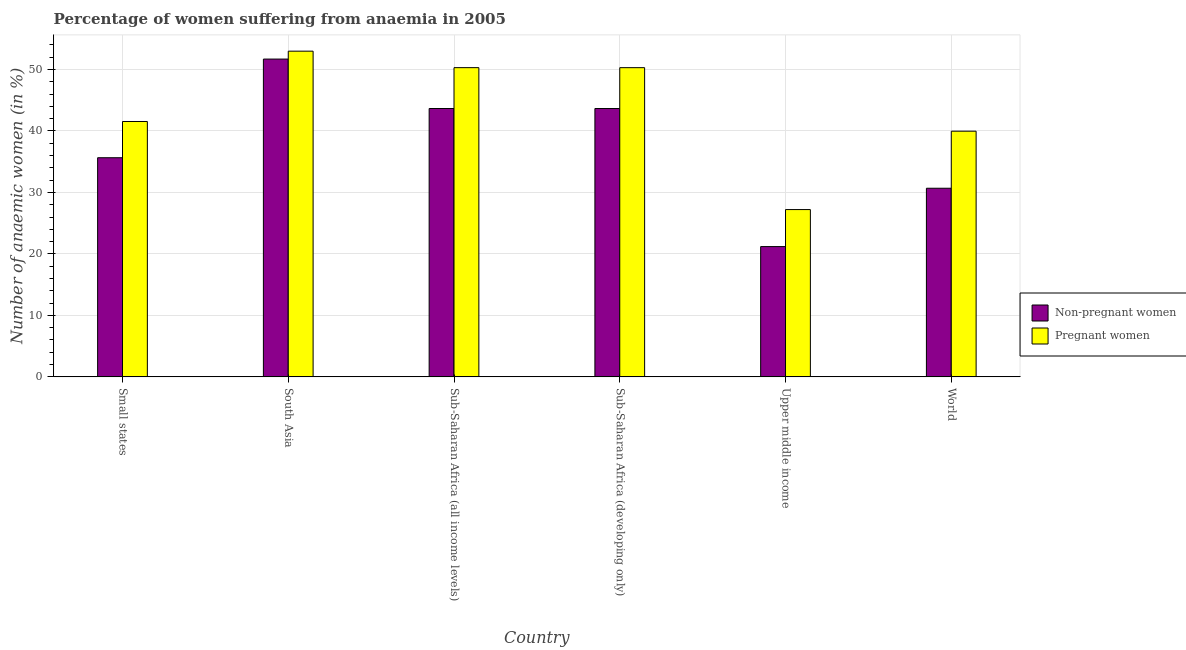How many different coloured bars are there?
Provide a succinct answer. 2. Are the number of bars per tick equal to the number of legend labels?
Make the answer very short. Yes. Are the number of bars on each tick of the X-axis equal?
Give a very brief answer. Yes. How many bars are there on the 4th tick from the left?
Ensure brevity in your answer.  2. What is the label of the 2nd group of bars from the left?
Your answer should be very brief. South Asia. What is the percentage of non-pregnant anaemic women in Sub-Saharan Africa (developing only)?
Offer a very short reply. 43.65. Across all countries, what is the maximum percentage of non-pregnant anaemic women?
Your answer should be very brief. 51.69. Across all countries, what is the minimum percentage of non-pregnant anaemic women?
Provide a succinct answer. 21.19. In which country was the percentage of pregnant anaemic women maximum?
Keep it short and to the point. South Asia. In which country was the percentage of non-pregnant anaemic women minimum?
Your answer should be compact. Upper middle income. What is the total percentage of pregnant anaemic women in the graph?
Your answer should be compact. 262.28. What is the difference between the percentage of non-pregnant anaemic women in South Asia and that in Upper middle income?
Ensure brevity in your answer.  30.5. What is the difference between the percentage of pregnant anaemic women in Small states and the percentage of non-pregnant anaemic women in Sub-Saharan Africa (developing only)?
Your response must be concise. -2.11. What is the average percentage of non-pregnant anaemic women per country?
Your answer should be very brief. 37.75. What is the difference between the percentage of non-pregnant anaemic women and percentage of pregnant anaemic women in Small states?
Provide a succinct answer. -5.89. What is the ratio of the percentage of non-pregnant anaemic women in South Asia to that in World?
Your answer should be compact. 1.68. Is the difference between the percentage of non-pregnant anaemic women in South Asia and Sub-Saharan Africa (all income levels) greater than the difference between the percentage of pregnant anaemic women in South Asia and Sub-Saharan Africa (all income levels)?
Keep it short and to the point. Yes. What is the difference between the highest and the second highest percentage of pregnant anaemic women?
Make the answer very short. 2.68. What is the difference between the highest and the lowest percentage of pregnant anaemic women?
Provide a succinct answer. 25.77. In how many countries, is the percentage of pregnant anaemic women greater than the average percentage of pregnant anaemic women taken over all countries?
Your answer should be very brief. 3. Is the sum of the percentage of non-pregnant anaemic women in Sub-Saharan Africa (developing only) and World greater than the maximum percentage of pregnant anaemic women across all countries?
Provide a succinct answer. Yes. What does the 1st bar from the left in Upper middle income represents?
Provide a short and direct response. Non-pregnant women. What does the 1st bar from the right in World represents?
Offer a terse response. Pregnant women. How many bars are there?
Provide a succinct answer. 12. How many countries are there in the graph?
Offer a very short reply. 6. What is the difference between two consecutive major ticks on the Y-axis?
Make the answer very short. 10. Are the values on the major ticks of Y-axis written in scientific E-notation?
Provide a succinct answer. No. Does the graph contain any zero values?
Keep it short and to the point. No. How many legend labels are there?
Keep it short and to the point. 2. How are the legend labels stacked?
Your answer should be very brief. Vertical. What is the title of the graph?
Ensure brevity in your answer.  Percentage of women suffering from anaemia in 2005. What is the label or title of the Y-axis?
Offer a very short reply. Number of anaemic women (in %). What is the Number of anaemic women (in %) of Non-pregnant women in Small states?
Keep it short and to the point. 35.65. What is the Number of anaemic women (in %) in Pregnant women in Small states?
Your response must be concise. 41.54. What is the Number of anaemic women (in %) of Non-pregnant women in South Asia?
Provide a short and direct response. 51.69. What is the Number of anaemic women (in %) in Pregnant women in South Asia?
Your answer should be very brief. 52.98. What is the Number of anaemic women (in %) in Non-pregnant women in Sub-Saharan Africa (all income levels)?
Keep it short and to the point. 43.65. What is the Number of anaemic women (in %) of Pregnant women in Sub-Saharan Africa (all income levels)?
Provide a succinct answer. 50.3. What is the Number of anaemic women (in %) of Non-pregnant women in Sub-Saharan Africa (developing only)?
Offer a very short reply. 43.65. What is the Number of anaemic women (in %) of Pregnant women in Sub-Saharan Africa (developing only)?
Provide a short and direct response. 50.29. What is the Number of anaemic women (in %) of Non-pregnant women in Upper middle income?
Ensure brevity in your answer.  21.19. What is the Number of anaemic women (in %) of Pregnant women in Upper middle income?
Provide a succinct answer. 27.21. What is the Number of anaemic women (in %) in Non-pregnant women in World?
Make the answer very short. 30.68. What is the Number of anaemic women (in %) in Pregnant women in World?
Give a very brief answer. 39.96. Across all countries, what is the maximum Number of anaemic women (in %) in Non-pregnant women?
Give a very brief answer. 51.69. Across all countries, what is the maximum Number of anaemic women (in %) of Pregnant women?
Offer a terse response. 52.98. Across all countries, what is the minimum Number of anaemic women (in %) in Non-pregnant women?
Make the answer very short. 21.19. Across all countries, what is the minimum Number of anaemic women (in %) of Pregnant women?
Your response must be concise. 27.21. What is the total Number of anaemic women (in %) of Non-pregnant women in the graph?
Provide a succinct answer. 226.51. What is the total Number of anaemic women (in %) of Pregnant women in the graph?
Make the answer very short. 262.28. What is the difference between the Number of anaemic women (in %) of Non-pregnant women in Small states and that in South Asia?
Provide a short and direct response. -16.05. What is the difference between the Number of anaemic women (in %) in Pregnant women in Small states and that in South Asia?
Ensure brevity in your answer.  -11.44. What is the difference between the Number of anaemic women (in %) of Non-pregnant women in Small states and that in Sub-Saharan Africa (all income levels)?
Ensure brevity in your answer.  -8.01. What is the difference between the Number of anaemic women (in %) in Pregnant women in Small states and that in Sub-Saharan Africa (all income levels)?
Provide a succinct answer. -8.76. What is the difference between the Number of anaemic women (in %) in Non-pregnant women in Small states and that in Sub-Saharan Africa (developing only)?
Your answer should be compact. -8. What is the difference between the Number of anaemic women (in %) of Pregnant women in Small states and that in Sub-Saharan Africa (developing only)?
Your answer should be compact. -8.75. What is the difference between the Number of anaemic women (in %) in Non-pregnant women in Small states and that in Upper middle income?
Offer a terse response. 14.45. What is the difference between the Number of anaemic women (in %) in Pregnant women in Small states and that in Upper middle income?
Your answer should be compact. 14.33. What is the difference between the Number of anaemic women (in %) in Non-pregnant women in Small states and that in World?
Your answer should be compact. 4.96. What is the difference between the Number of anaemic women (in %) of Pregnant women in Small states and that in World?
Ensure brevity in your answer.  1.58. What is the difference between the Number of anaemic women (in %) in Non-pregnant women in South Asia and that in Sub-Saharan Africa (all income levels)?
Your response must be concise. 8.04. What is the difference between the Number of anaemic women (in %) in Pregnant women in South Asia and that in Sub-Saharan Africa (all income levels)?
Make the answer very short. 2.68. What is the difference between the Number of anaemic women (in %) of Non-pregnant women in South Asia and that in Sub-Saharan Africa (developing only)?
Provide a short and direct response. 8.04. What is the difference between the Number of anaemic women (in %) in Pregnant women in South Asia and that in Sub-Saharan Africa (developing only)?
Make the answer very short. 2.69. What is the difference between the Number of anaemic women (in %) of Non-pregnant women in South Asia and that in Upper middle income?
Give a very brief answer. 30.5. What is the difference between the Number of anaemic women (in %) in Pregnant women in South Asia and that in Upper middle income?
Keep it short and to the point. 25.77. What is the difference between the Number of anaemic women (in %) in Non-pregnant women in South Asia and that in World?
Ensure brevity in your answer.  21.01. What is the difference between the Number of anaemic women (in %) in Pregnant women in South Asia and that in World?
Your answer should be very brief. 13.02. What is the difference between the Number of anaemic women (in %) in Non-pregnant women in Sub-Saharan Africa (all income levels) and that in Sub-Saharan Africa (developing only)?
Offer a very short reply. 0. What is the difference between the Number of anaemic women (in %) in Pregnant women in Sub-Saharan Africa (all income levels) and that in Sub-Saharan Africa (developing only)?
Your response must be concise. 0. What is the difference between the Number of anaemic women (in %) in Non-pregnant women in Sub-Saharan Africa (all income levels) and that in Upper middle income?
Keep it short and to the point. 22.46. What is the difference between the Number of anaemic women (in %) in Pregnant women in Sub-Saharan Africa (all income levels) and that in Upper middle income?
Your response must be concise. 23.09. What is the difference between the Number of anaemic women (in %) in Non-pregnant women in Sub-Saharan Africa (all income levels) and that in World?
Keep it short and to the point. 12.97. What is the difference between the Number of anaemic women (in %) in Pregnant women in Sub-Saharan Africa (all income levels) and that in World?
Provide a succinct answer. 10.33. What is the difference between the Number of anaemic women (in %) of Non-pregnant women in Sub-Saharan Africa (developing only) and that in Upper middle income?
Make the answer very short. 22.46. What is the difference between the Number of anaemic women (in %) of Pregnant women in Sub-Saharan Africa (developing only) and that in Upper middle income?
Make the answer very short. 23.08. What is the difference between the Number of anaemic women (in %) of Non-pregnant women in Sub-Saharan Africa (developing only) and that in World?
Your response must be concise. 12.97. What is the difference between the Number of anaemic women (in %) in Pregnant women in Sub-Saharan Africa (developing only) and that in World?
Provide a short and direct response. 10.33. What is the difference between the Number of anaemic women (in %) of Non-pregnant women in Upper middle income and that in World?
Provide a short and direct response. -9.49. What is the difference between the Number of anaemic women (in %) of Pregnant women in Upper middle income and that in World?
Provide a succinct answer. -12.75. What is the difference between the Number of anaemic women (in %) in Non-pregnant women in Small states and the Number of anaemic women (in %) in Pregnant women in South Asia?
Offer a very short reply. -17.33. What is the difference between the Number of anaemic women (in %) in Non-pregnant women in Small states and the Number of anaemic women (in %) in Pregnant women in Sub-Saharan Africa (all income levels)?
Give a very brief answer. -14.65. What is the difference between the Number of anaemic women (in %) of Non-pregnant women in Small states and the Number of anaemic women (in %) of Pregnant women in Sub-Saharan Africa (developing only)?
Keep it short and to the point. -14.65. What is the difference between the Number of anaemic women (in %) of Non-pregnant women in Small states and the Number of anaemic women (in %) of Pregnant women in Upper middle income?
Make the answer very short. 8.43. What is the difference between the Number of anaemic women (in %) of Non-pregnant women in Small states and the Number of anaemic women (in %) of Pregnant women in World?
Keep it short and to the point. -4.32. What is the difference between the Number of anaemic women (in %) in Non-pregnant women in South Asia and the Number of anaemic women (in %) in Pregnant women in Sub-Saharan Africa (all income levels)?
Provide a succinct answer. 1.4. What is the difference between the Number of anaemic women (in %) of Non-pregnant women in South Asia and the Number of anaemic women (in %) of Pregnant women in Sub-Saharan Africa (developing only)?
Give a very brief answer. 1.4. What is the difference between the Number of anaemic women (in %) of Non-pregnant women in South Asia and the Number of anaemic women (in %) of Pregnant women in Upper middle income?
Make the answer very short. 24.48. What is the difference between the Number of anaemic women (in %) of Non-pregnant women in South Asia and the Number of anaemic women (in %) of Pregnant women in World?
Provide a short and direct response. 11.73. What is the difference between the Number of anaemic women (in %) in Non-pregnant women in Sub-Saharan Africa (all income levels) and the Number of anaemic women (in %) in Pregnant women in Sub-Saharan Africa (developing only)?
Provide a succinct answer. -6.64. What is the difference between the Number of anaemic women (in %) in Non-pregnant women in Sub-Saharan Africa (all income levels) and the Number of anaemic women (in %) in Pregnant women in Upper middle income?
Your response must be concise. 16.44. What is the difference between the Number of anaemic women (in %) of Non-pregnant women in Sub-Saharan Africa (all income levels) and the Number of anaemic women (in %) of Pregnant women in World?
Give a very brief answer. 3.69. What is the difference between the Number of anaemic women (in %) in Non-pregnant women in Sub-Saharan Africa (developing only) and the Number of anaemic women (in %) in Pregnant women in Upper middle income?
Your answer should be compact. 16.44. What is the difference between the Number of anaemic women (in %) of Non-pregnant women in Sub-Saharan Africa (developing only) and the Number of anaemic women (in %) of Pregnant women in World?
Your answer should be very brief. 3.69. What is the difference between the Number of anaemic women (in %) in Non-pregnant women in Upper middle income and the Number of anaemic women (in %) in Pregnant women in World?
Ensure brevity in your answer.  -18.77. What is the average Number of anaemic women (in %) of Non-pregnant women per country?
Ensure brevity in your answer.  37.75. What is the average Number of anaemic women (in %) in Pregnant women per country?
Provide a succinct answer. 43.71. What is the difference between the Number of anaemic women (in %) in Non-pregnant women and Number of anaemic women (in %) in Pregnant women in Small states?
Provide a succinct answer. -5.89. What is the difference between the Number of anaemic women (in %) of Non-pregnant women and Number of anaemic women (in %) of Pregnant women in South Asia?
Your answer should be compact. -1.29. What is the difference between the Number of anaemic women (in %) of Non-pregnant women and Number of anaemic women (in %) of Pregnant women in Sub-Saharan Africa (all income levels)?
Provide a short and direct response. -6.65. What is the difference between the Number of anaemic women (in %) in Non-pregnant women and Number of anaemic women (in %) in Pregnant women in Sub-Saharan Africa (developing only)?
Your answer should be compact. -6.64. What is the difference between the Number of anaemic women (in %) of Non-pregnant women and Number of anaemic women (in %) of Pregnant women in Upper middle income?
Offer a very short reply. -6.02. What is the difference between the Number of anaemic women (in %) of Non-pregnant women and Number of anaemic women (in %) of Pregnant women in World?
Offer a very short reply. -9.28. What is the ratio of the Number of anaemic women (in %) in Non-pregnant women in Small states to that in South Asia?
Offer a terse response. 0.69. What is the ratio of the Number of anaemic women (in %) in Pregnant women in Small states to that in South Asia?
Your answer should be very brief. 0.78. What is the ratio of the Number of anaemic women (in %) of Non-pregnant women in Small states to that in Sub-Saharan Africa (all income levels)?
Your answer should be compact. 0.82. What is the ratio of the Number of anaemic women (in %) in Pregnant women in Small states to that in Sub-Saharan Africa (all income levels)?
Offer a terse response. 0.83. What is the ratio of the Number of anaemic women (in %) of Non-pregnant women in Small states to that in Sub-Saharan Africa (developing only)?
Your response must be concise. 0.82. What is the ratio of the Number of anaemic women (in %) in Pregnant women in Small states to that in Sub-Saharan Africa (developing only)?
Keep it short and to the point. 0.83. What is the ratio of the Number of anaemic women (in %) of Non-pregnant women in Small states to that in Upper middle income?
Your answer should be very brief. 1.68. What is the ratio of the Number of anaemic women (in %) of Pregnant women in Small states to that in Upper middle income?
Provide a short and direct response. 1.53. What is the ratio of the Number of anaemic women (in %) in Non-pregnant women in Small states to that in World?
Offer a terse response. 1.16. What is the ratio of the Number of anaemic women (in %) of Pregnant women in Small states to that in World?
Make the answer very short. 1.04. What is the ratio of the Number of anaemic women (in %) of Non-pregnant women in South Asia to that in Sub-Saharan Africa (all income levels)?
Provide a succinct answer. 1.18. What is the ratio of the Number of anaemic women (in %) in Pregnant women in South Asia to that in Sub-Saharan Africa (all income levels)?
Your answer should be very brief. 1.05. What is the ratio of the Number of anaemic women (in %) in Non-pregnant women in South Asia to that in Sub-Saharan Africa (developing only)?
Your response must be concise. 1.18. What is the ratio of the Number of anaemic women (in %) in Pregnant women in South Asia to that in Sub-Saharan Africa (developing only)?
Provide a succinct answer. 1.05. What is the ratio of the Number of anaemic women (in %) of Non-pregnant women in South Asia to that in Upper middle income?
Offer a very short reply. 2.44. What is the ratio of the Number of anaemic women (in %) in Pregnant women in South Asia to that in Upper middle income?
Offer a terse response. 1.95. What is the ratio of the Number of anaemic women (in %) of Non-pregnant women in South Asia to that in World?
Your answer should be very brief. 1.68. What is the ratio of the Number of anaemic women (in %) of Pregnant women in South Asia to that in World?
Offer a very short reply. 1.33. What is the ratio of the Number of anaemic women (in %) in Pregnant women in Sub-Saharan Africa (all income levels) to that in Sub-Saharan Africa (developing only)?
Ensure brevity in your answer.  1. What is the ratio of the Number of anaemic women (in %) in Non-pregnant women in Sub-Saharan Africa (all income levels) to that in Upper middle income?
Your answer should be very brief. 2.06. What is the ratio of the Number of anaemic women (in %) of Pregnant women in Sub-Saharan Africa (all income levels) to that in Upper middle income?
Give a very brief answer. 1.85. What is the ratio of the Number of anaemic women (in %) of Non-pregnant women in Sub-Saharan Africa (all income levels) to that in World?
Offer a terse response. 1.42. What is the ratio of the Number of anaemic women (in %) of Pregnant women in Sub-Saharan Africa (all income levels) to that in World?
Keep it short and to the point. 1.26. What is the ratio of the Number of anaemic women (in %) of Non-pregnant women in Sub-Saharan Africa (developing only) to that in Upper middle income?
Your answer should be compact. 2.06. What is the ratio of the Number of anaemic women (in %) in Pregnant women in Sub-Saharan Africa (developing only) to that in Upper middle income?
Give a very brief answer. 1.85. What is the ratio of the Number of anaemic women (in %) of Non-pregnant women in Sub-Saharan Africa (developing only) to that in World?
Ensure brevity in your answer.  1.42. What is the ratio of the Number of anaemic women (in %) of Pregnant women in Sub-Saharan Africa (developing only) to that in World?
Provide a succinct answer. 1.26. What is the ratio of the Number of anaemic women (in %) in Non-pregnant women in Upper middle income to that in World?
Give a very brief answer. 0.69. What is the ratio of the Number of anaemic women (in %) of Pregnant women in Upper middle income to that in World?
Make the answer very short. 0.68. What is the difference between the highest and the second highest Number of anaemic women (in %) in Non-pregnant women?
Give a very brief answer. 8.04. What is the difference between the highest and the second highest Number of anaemic women (in %) in Pregnant women?
Your answer should be very brief. 2.68. What is the difference between the highest and the lowest Number of anaemic women (in %) of Non-pregnant women?
Your answer should be compact. 30.5. What is the difference between the highest and the lowest Number of anaemic women (in %) of Pregnant women?
Provide a succinct answer. 25.77. 